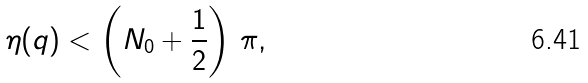<formula> <loc_0><loc_0><loc_500><loc_500>\eta ( q ) < \left ( N _ { 0 } + \frac { 1 } { 2 } \right ) \, \pi ,</formula> 